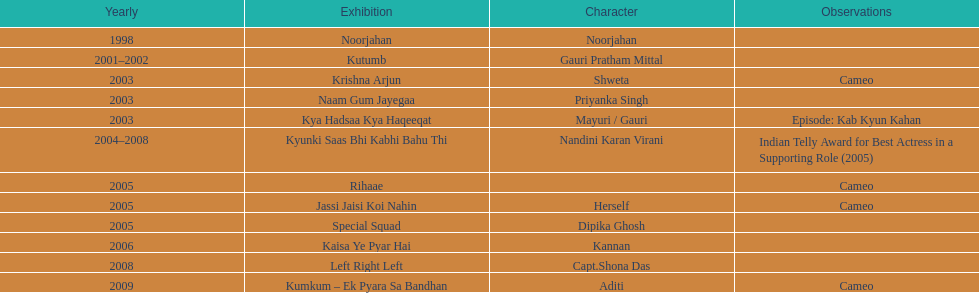In total, how many different tv series has gauri tejwani either starred or cameoed in? 11. 